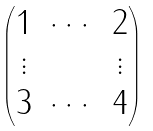<formula> <loc_0><loc_0><loc_500><loc_500>\begin{pmatrix} 1 & \cdots & 2 \\ \vdots & & \vdots \\ 3 & \cdots & 4 \end{pmatrix}</formula> 